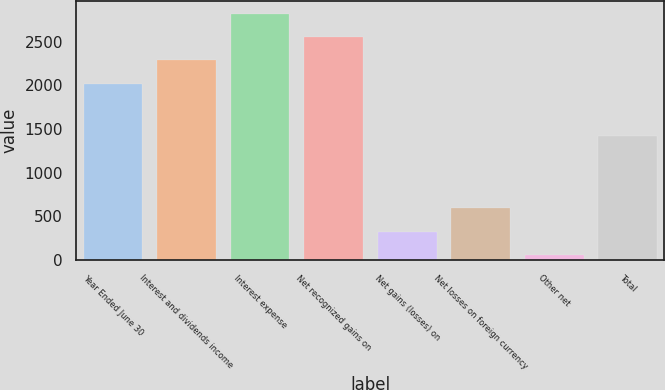Convert chart. <chart><loc_0><loc_0><loc_500><loc_500><bar_chart><fcel>Year Ended June 30<fcel>Interest and dividends income<fcel>Interest expense<fcel>Net recognized gains on<fcel>Net gains (losses) on<fcel>Net losses on foreign currency<fcel>Other net<fcel>Total<nl><fcel>2018<fcel>2285.4<fcel>2820.2<fcel>2552.8<fcel>326.4<fcel>593.8<fcel>59<fcel>1416<nl></chart> 